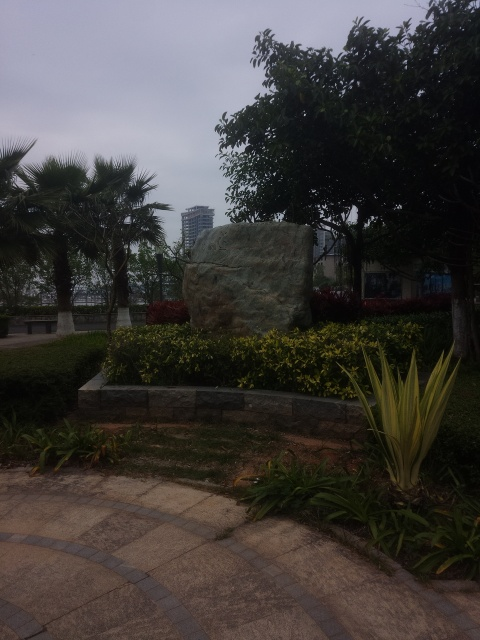Can the time of day affect the visual impact of this photo? Absolutely, the time of day can significantly affect the photo's visual impact. For instance, early morning or late afternoon light, known as the golden hour, can cast warm, soft light that enhances the textures and colors in the garden. Conversely, the current overcast conditions produce flat lighting, which might not do justice to the landscape's potential vibrancy. What would be the optimal season to capture this garden at its most beautiful? The optimal season to capture this garden in its full glory would likely be spring or early summer. During these months, the plants are in full bloom, and the lush greenery combined with floral colors would create a more dynamic and appealing photograph. 